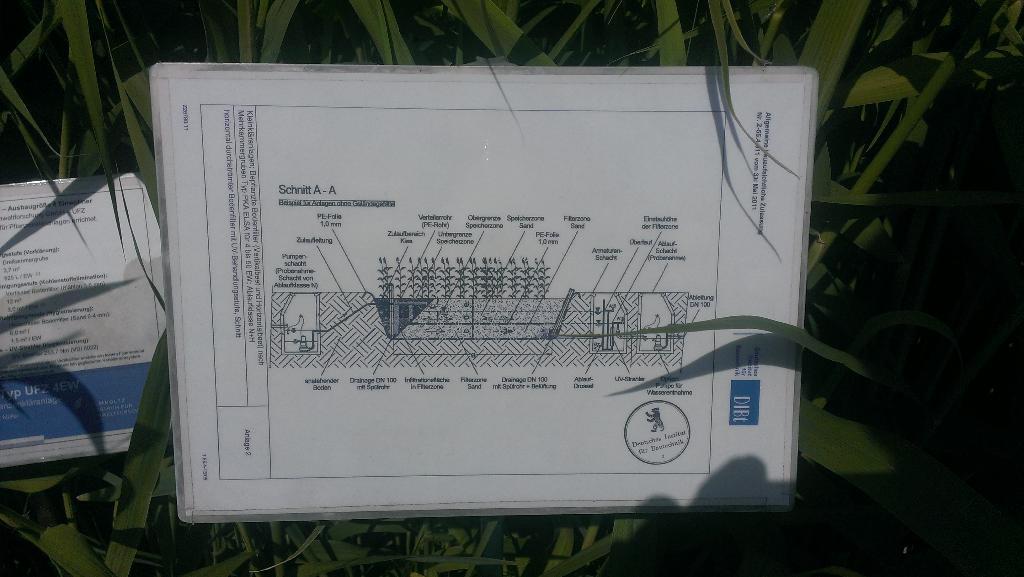Describe this image in one or two sentences. In this image in the center there is one board, and on the board there is some text. Beside the board there is another board, and in the background there are some plants. 